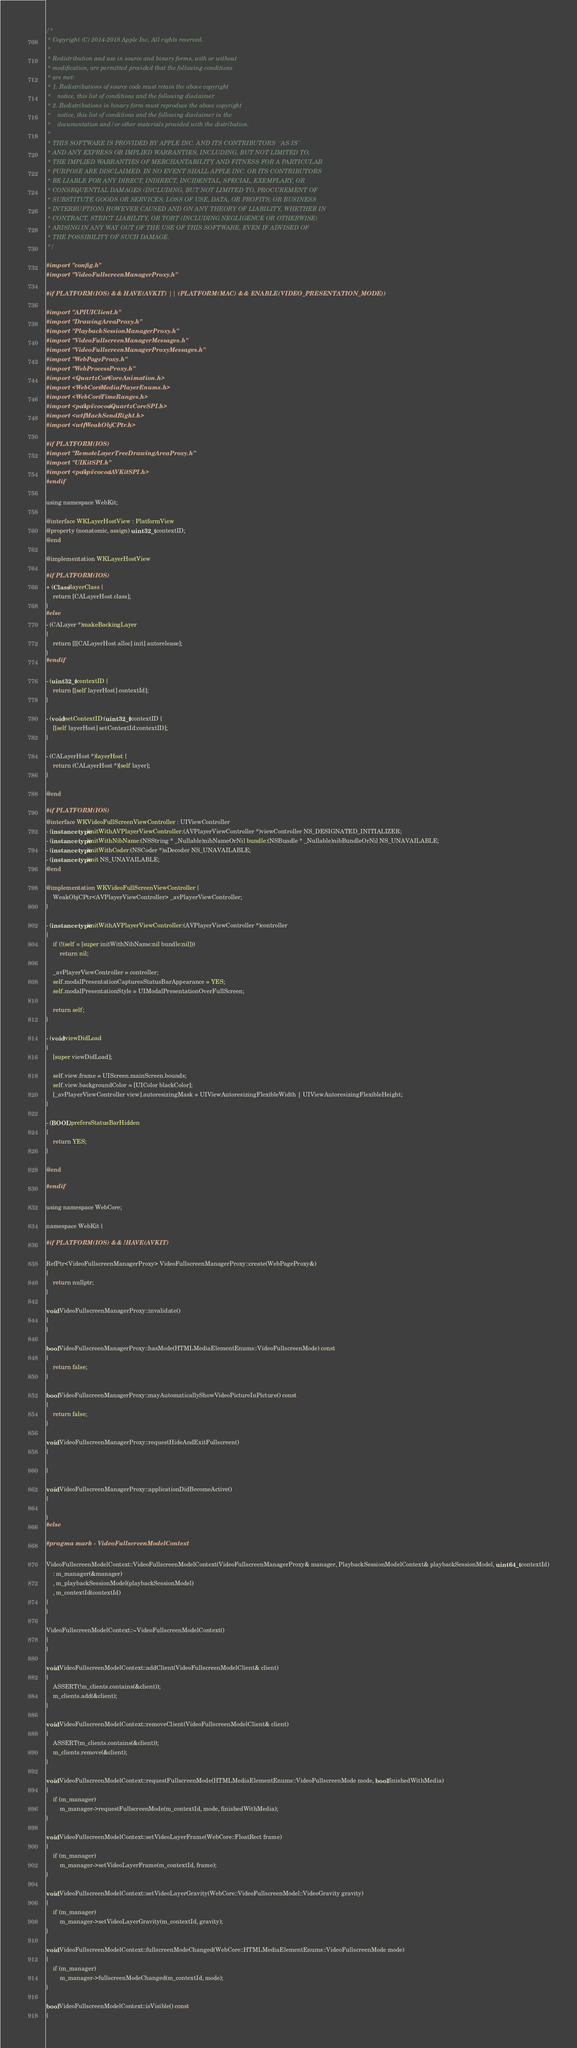<code> <loc_0><loc_0><loc_500><loc_500><_ObjectiveC_>/*
 * Copyright (C) 2014-2018 Apple Inc. All rights reserved.
 *
 * Redistribution and use in source and binary forms, with or without
 * modification, are permitted provided that the following conditions
 * are met:
 * 1. Redistributions of source code must retain the above copyright
 *    notice, this list of conditions and the following disclaimer.
 * 2. Redistributions in binary form must reproduce the above copyright
 *    notice, this list of conditions and the following disclaimer in the
 *    documentation and/or other materials provided with the distribution.
 *
 * THIS SOFTWARE IS PROVIDED BY APPLE INC. AND ITS CONTRIBUTORS ``AS IS''
 * AND ANY EXPRESS OR IMPLIED WARRANTIES, INCLUDING, BUT NOT LIMITED TO,
 * THE IMPLIED WARRANTIES OF MERCHANTABILITY AND FITNESS FOR A PARTICULAR
 * PURPOSE ARE DISCLAIMED. IN NO EVENT SHALL APPLE INC. OR ITS CONTRIBUTORS
 * BE LIABLE FOR ANY DIRECT, INDIRECT, INCIDENTAL, SPECIAL, EXEMPLARY, OR
 * CONSEQUENTIAL DAMAGES (INCLUDING, BUT NOT LIMITED TO, PROCUREMENT OF
 * SUBSTITUTE GOODS OR SERVICES; LOSS OF USE, DATA, OR PROFITS; OR BUSINESS
 * INTERRUPTION) HOWEVER CAUSED AND ON ANY THEORY OF LIABILITY, WHETHER IN
 * CONTRACT, STRICT LIABILITY, OR TORT (INCLUDING NEGLIGENCE OR OTHERWISE)
 * ARISING IN ANY WAY OUT OF THE USE OF THIS SOFTWARE, EVEN IF ADVISED OF
 * THE POSSIBILITY OF SUCH DAMAGE.
 */

#import "config.h"
#import "VideoFullscreenManagerProxy.h"

#if PLATFORM(IOS) && HAVE(AVKIT) || (PLATFORM(MAC) && ENABLE(VIDEO_PRESENTATION_MODE))

#import "APIUIClient.h"
#import "DrawingAreaProxy.h"
#import "PlaybackSessionManagerProxy.h"
#import "VideoFullscreenManagerMessages.h"
#import "VideoFullscreenManagerProxyMessages.h"
#import "WebPageProxy.h"
#import "WebProcessProxy.h"
#import <QuartzCore/CoreAnimation.h>
#import <WebCore/MediaPlayerEnums.h>
#import <WebCore/TimeRanges.h>
#import <pal/spi/cocoa/QuartzCoreSPI.h>
#import <wtf/MachSendRight.h>
#import <wtf/WeakObjCPtr.h>

#if PLATFORM(IOS)
#import "RemoteLayerTreeDrawingAreaProxy.h"
#import "UIKitSPI.h"
#import <pal/spi/cocoa/AVKitSPI.h>
#endif

using namespace WebKit;

@interface WKLayerHostView : PlatformView
@property (nonatomic, assign) uint32_t contextID;
@end

@implementation WKLayerHostView

#if PLATFORM(IOS)
+ (Class)layerClass {
    return [CALayerHost class];
}
#else
- (CALayer *)makeBackingLayer
{
    return [[[CALayerHost alloc] init] autorelease];
}
#endif

- (uint32_t)contextID {
    return [[self layerHost] contextId];
}

- (void)setContextID:(uint32_t)contextID {
    [[self layerHost] setContextId:contextID];
}

- (CALayerHost *)layerHost {
    return (CALayerHost *)[self layer];
}

@end

#if PLATFORM(IOS)
@interface WKVideoFullScreenViewController : UIViewController
- (instancetype)initWithAVPlayerViewController:(AVPlayerViewController *)viewController NS_DESIGNATED_INITIALIZER;
- (instancetype)initWithNibName:(NSString * _Nullable)nibNameOrNil bundle:(NSBundle * _Nullable)nibBundleOrNil NS_UNAVAILABLE;
- (instancetype)initWithCoder:(NSCoder *)aDecoder NS_UNAVAILABLE;
- (instancetype)init NS_UNAVAILABLE;
@end

@implementation WKVideoFullScreenViewController {
    WeakObjCPtr<AVPlayerViewController> _avPlayerViewController;
}

- (instancetype)initWithAVPlayerViewController:(AVPlayerViewController *)controller
{
    if (!(self = [super initWithNibName:nil bundle:nil]))
        return nil;

    _avPlayerViewController = controller;
    self.modalPresentationCapturesStatusBarAppearance = YES;
    self.modalPresentationStyle = UIModalPresentationOverFullScreen;

    return self;
}

- (void)viewDidLoad
{
    [super viewDidLoad];

    self.view.frame = UIScreen.mainScreen.bounds;
    self.view.backgroundColor = [UIColor blackColor];
    [_avPlayerViewController view].autoresizingMask = UIViewAutoresizingFlexibleWidth | UIViewAutoresizingFlexibleHeight;
}

- (BOOL)prefersStatusBarHidden
{
    return YES;
}

@end

#endif

using namespace WebCore;

namespace WebKit {

#if PLATFORM(IOS) && !HAVE(AVKIT)

RefPtr<VideoFullscreenManagerProxy> VideoFullscreenManagerProxy::create(WebPageProxy&)
{
    return nullptr;
}

void VideoFullscreenManagerProxy::invalidate()
{
}

bool VideoFullscreenManagerProxy::hasMode(HTMLMediaElementEnums::VideoFullscreenMode) const
{
    return false;
}

bool VideoFullscreenManagerProxy::mayAutomaticallyShowVideoPictureInPicture() const
{
    return false;
}

void VideoFullscreenManagerProxy::requestHideAndExitFullscreen()
{

}

void VideoFullscreenManagerProxy::applicationDidBecomeActive()
{

}
#else

#pragma mark - VideoFullscreenModelContext

VideoFullscreenModelContext::VideoFullscreenModelContext(VideoFullscreenManagerProxy& manager, PlaybackSessionModelContext& playbackSessionModel, uint64_t contextId)
    : m_manager(&manager)
    , m_playbackSessionModel(playbackSessionModel)
    , m_contextId(contextId)
{
}

VideoFullscreenModelContext::~VideoFullscreenModelContext()
{
}

void VideoFullscreenModelContext::addClient(VideoFullscreenModelClient& client)
{
    ASSERT(!m_clients.contains(&client));
    m_clients.add(&client);
}

void VideoFullscreenModelContext::removeClient(VideoFullscreenModelClient& client)
{
    ASSERT(m_clients.contains(&client));
    m_clients.remove(&client);
}

void VideoFullscreenModelContext::requestFullscreenMode(HTMLMediaElementEnums::VideoFullscreenMode mode, bool finishedWithMedia)
{
    if (m_manager)
        m_manager->requestFullscreenMode(m_contextId, mode, finishedWithMedia);
}

void VideoFullscreenModelContext::setVideoLayerFrame(WebCore::FloatRect frame)
{
    if (m_manager)
        m_manager->setVideoLayerFrame(m_contextId, frame);
}

void VideoFullscreenModelContext::setVideoLayerGravity(WebCore::VideoFullscreenModel::VideoGravity gravity)
{
    if (m_manager)
        m_manager->setVideoLayerGravity(m_contextId, gravity);
}

void VideoFullscreenModelContext::fullscreenModeChanged(WebCore::HTMLMediaElementEnums::VideoFullscreenMode mode)
{
    if (m_manager)
        m_manager->fullscreenModeChanged(m_contextId, mode);
}

bool VideoFullscreenModelContext::isVisible() const
{</code> 